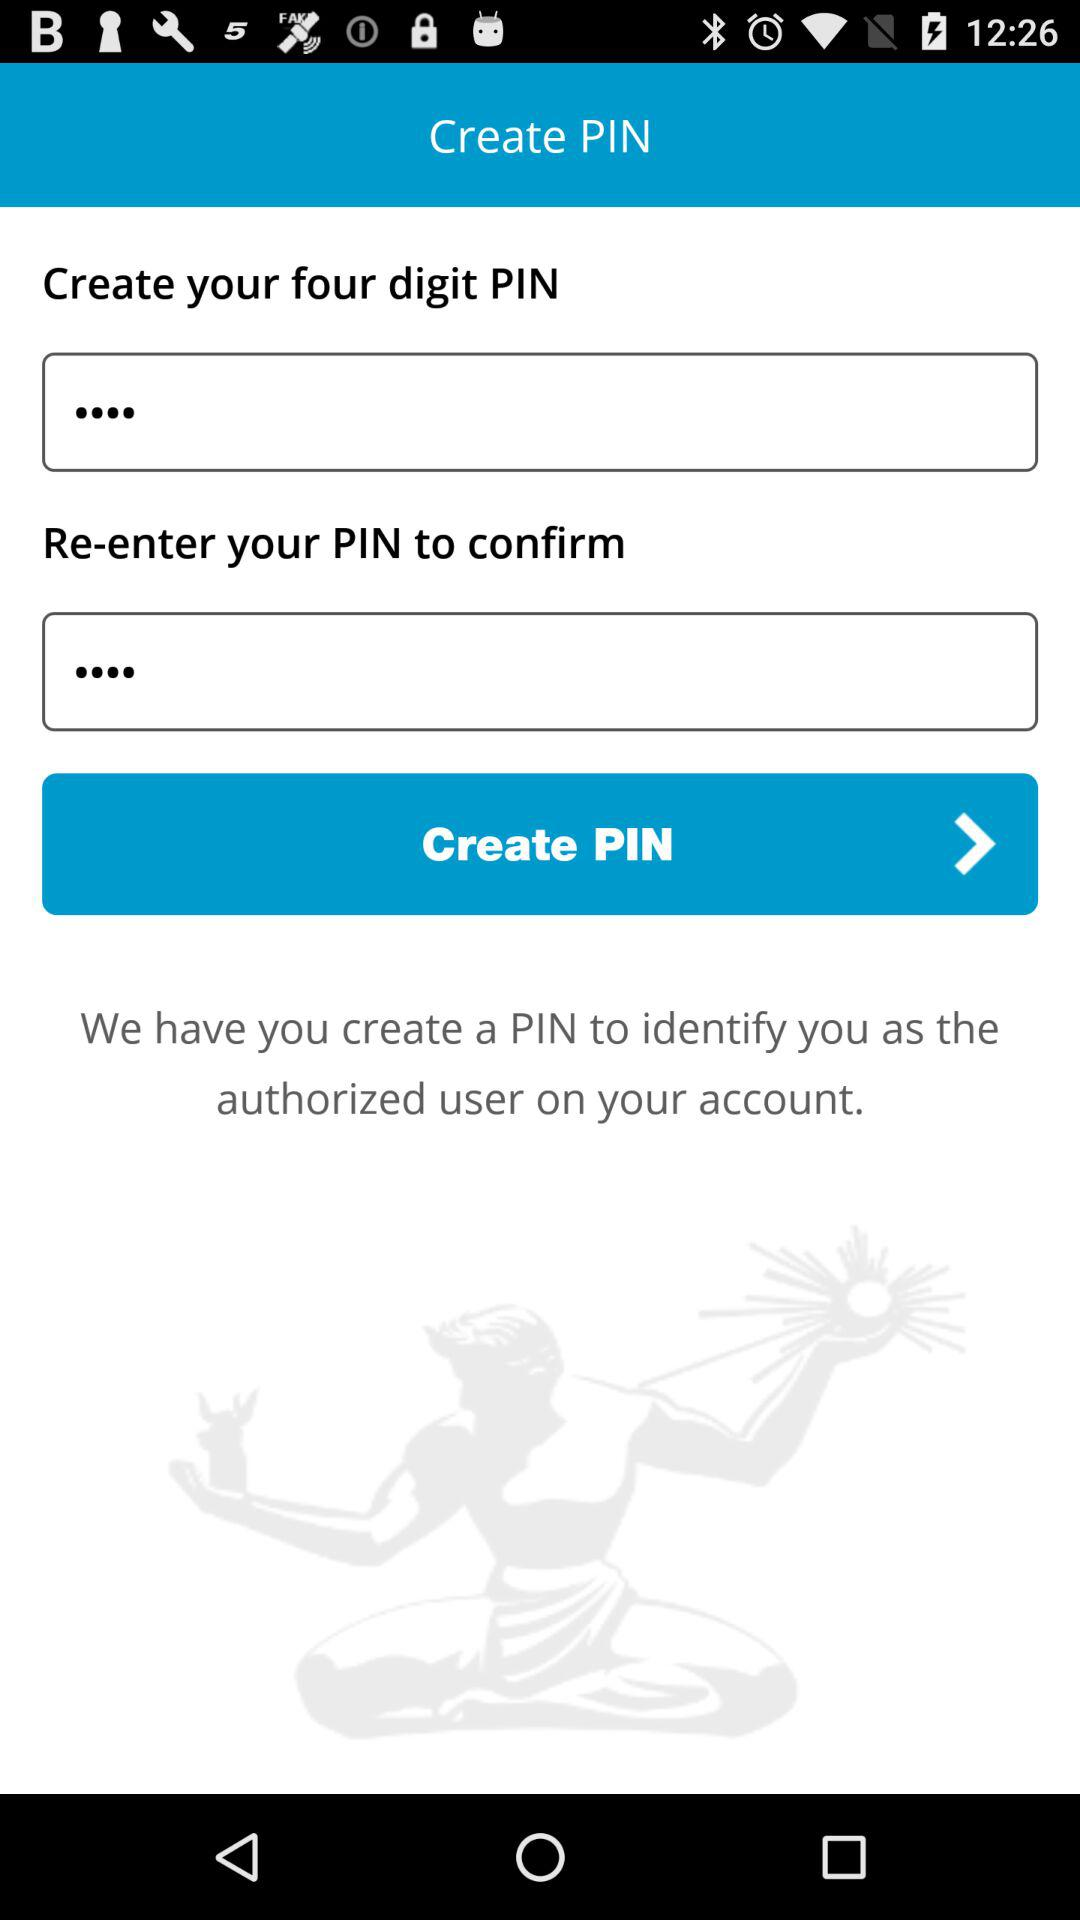How many digits are in the PIN that I need to create?
Answer the question using a single word or phrase. 4 